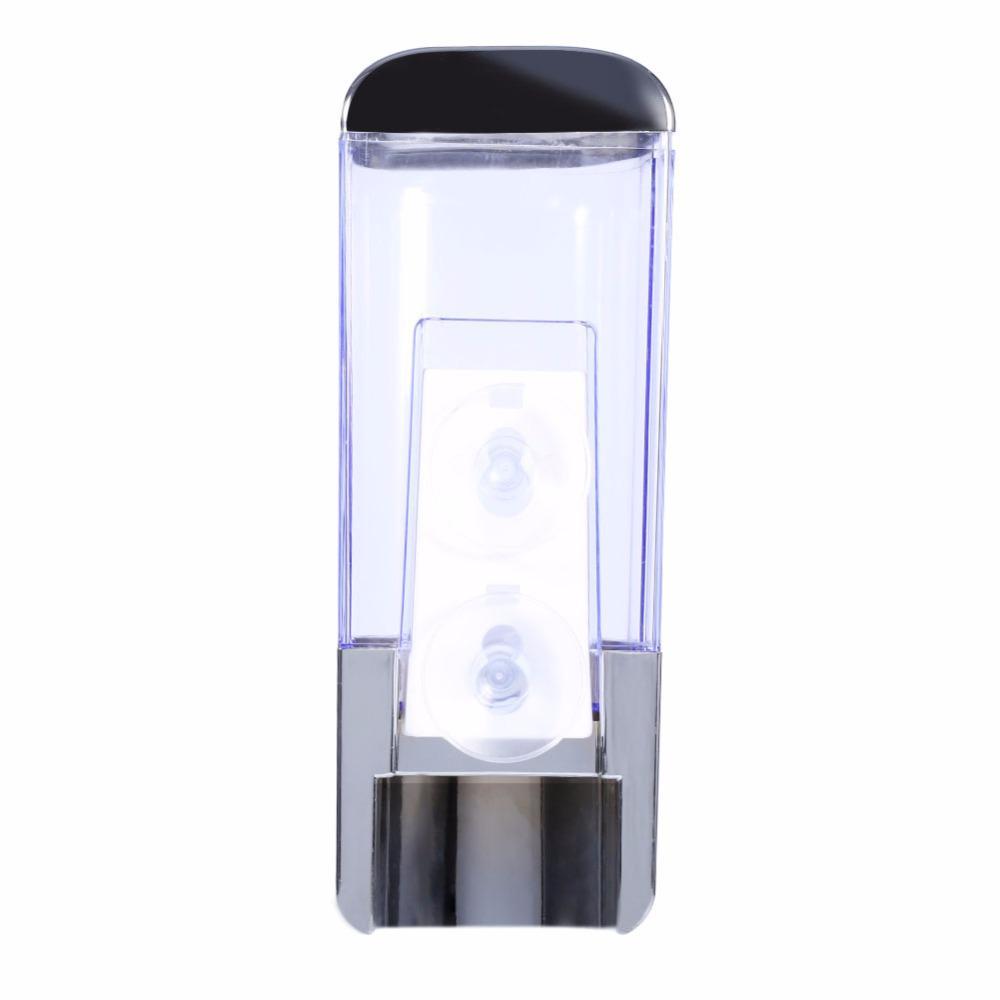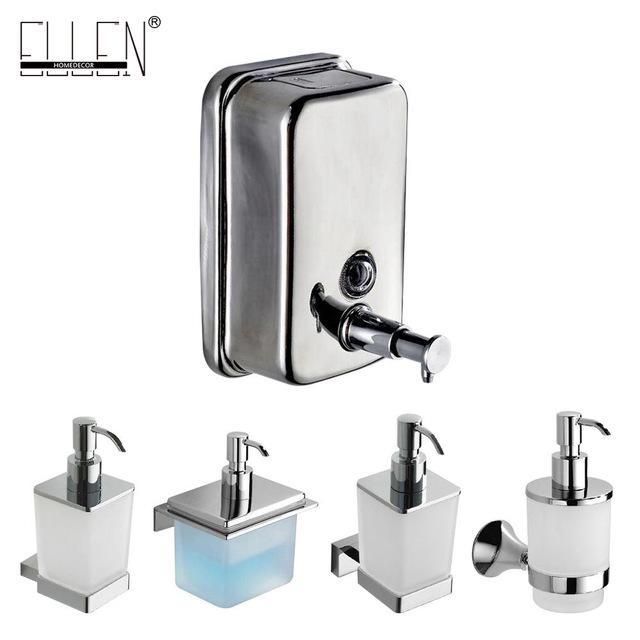The first image is the image on the left, the second image is the image on the right. Considering the images on both sides, is "There are two sinks, and none of them have legs." valid? Answer yes or no. No. The first image is the image on the left, the second image is the image on the right. Considering the images on both sides, is "The left and right image contains the same number of  hanging sinks." valid? Answer yes or no. No. 